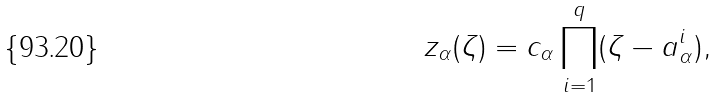Convert formula to latex. <formula><loc_0><loc_0><loc_500><loc_500>z _ { \alpha } ( \zeta ) = c _ { \alpha } \prod _ { i = 1 } ^ { q } ( \zeta - a _ { \alpha } ^ { i } ) ,</formula> 